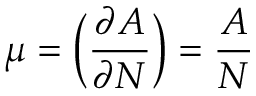<formula> <loc_0><loc_0><loc_500><loc_500>\mu = \left ( { \frac { \partial A } { \partial N } } \right ) = { \frac { A } { N } }</formula> 